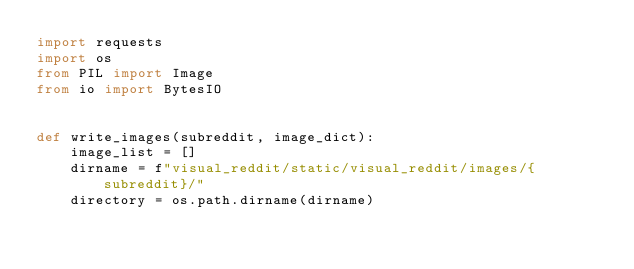<code> <loc_0><loc_0><loc_500><loc_500><_Python_>import requests
import os
from PIL import Image
from io import BytesIO


def write_images(subreddit, image_dict):
    image_list = []
    dirname = f"visual_reddit/static/visual_reddit/images/{subreddit}/"
    directory = os.path.dirname(dirname)</code> 